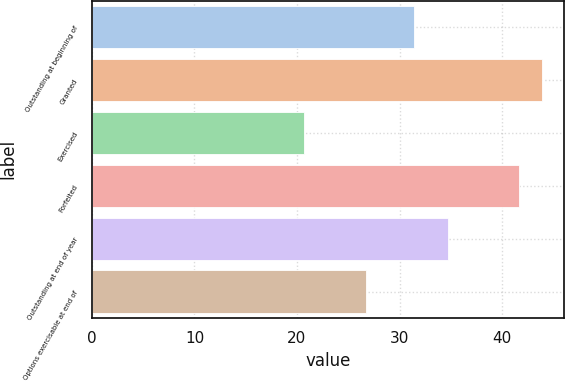Convert chart. <chart><loc_0><loc_0><loc_500><loc_500><bar_chart><fcel>Outstanding at beginning of<fcel>Granted<fcel>Exercised<fcel>Forfeited<fcel>Outstanding at end of year<fcel>Options exercisable at end of<nl><fcel>31.43<fcel>43.86<fcel>20.72<fcel>41.7<fcel>34.69<fcel>26.76<nl></chart> 